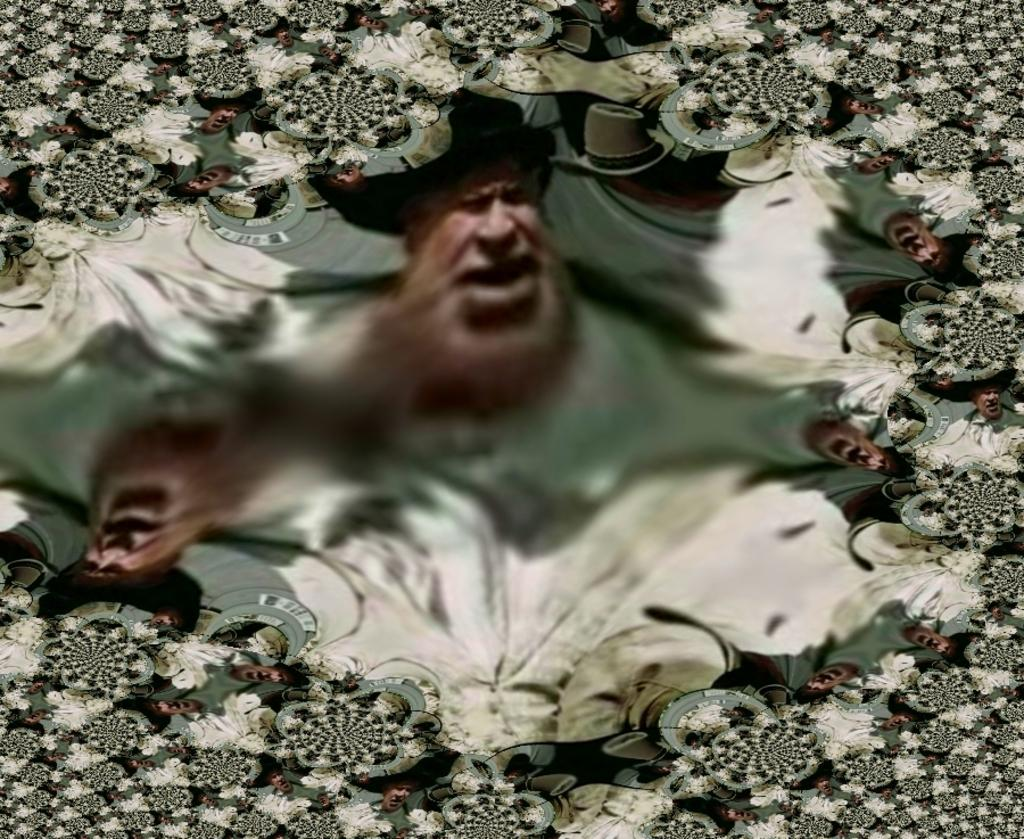What is the main subject of the image? The main subject of the image is a person, as there are many photos of them. Can you describe the content of the photos? The photos in the image are of a person, but the specific details of the photos cannot be determined from the provided facts. How many minutes does it take for the person to kick the ball in the image? There is no ball or indication of a kick in the image; it only contains photos of a person. 